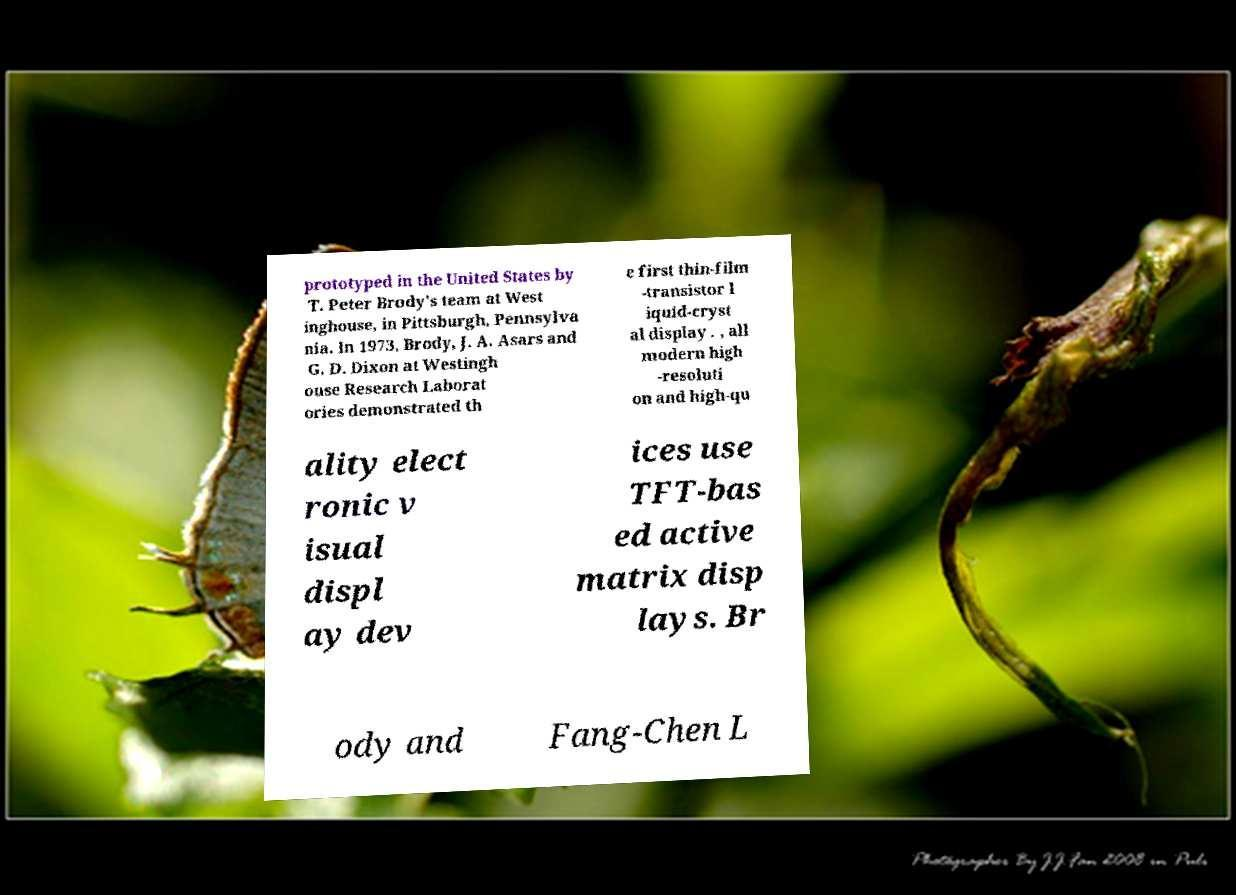There's text embedded in this image that I need extracted. Can you transcribe it verbatim? prototyped in the United States by T. Peter Brody's team at West inghouse, in Pittsburgh, Pennsylva nia. In 1973, Brody, J. A. Asars and G. D. Dixon at Westingh ouse Research Laborat ories demonstrated th e first thin-film -transistor l iquid-cryst al display . , all modern high -resoluti on and high-qu ality elect ronic v isual displ ay dev ices use TFT-bas ed active matrix disp lays. Br ody and Fang-Chen L 